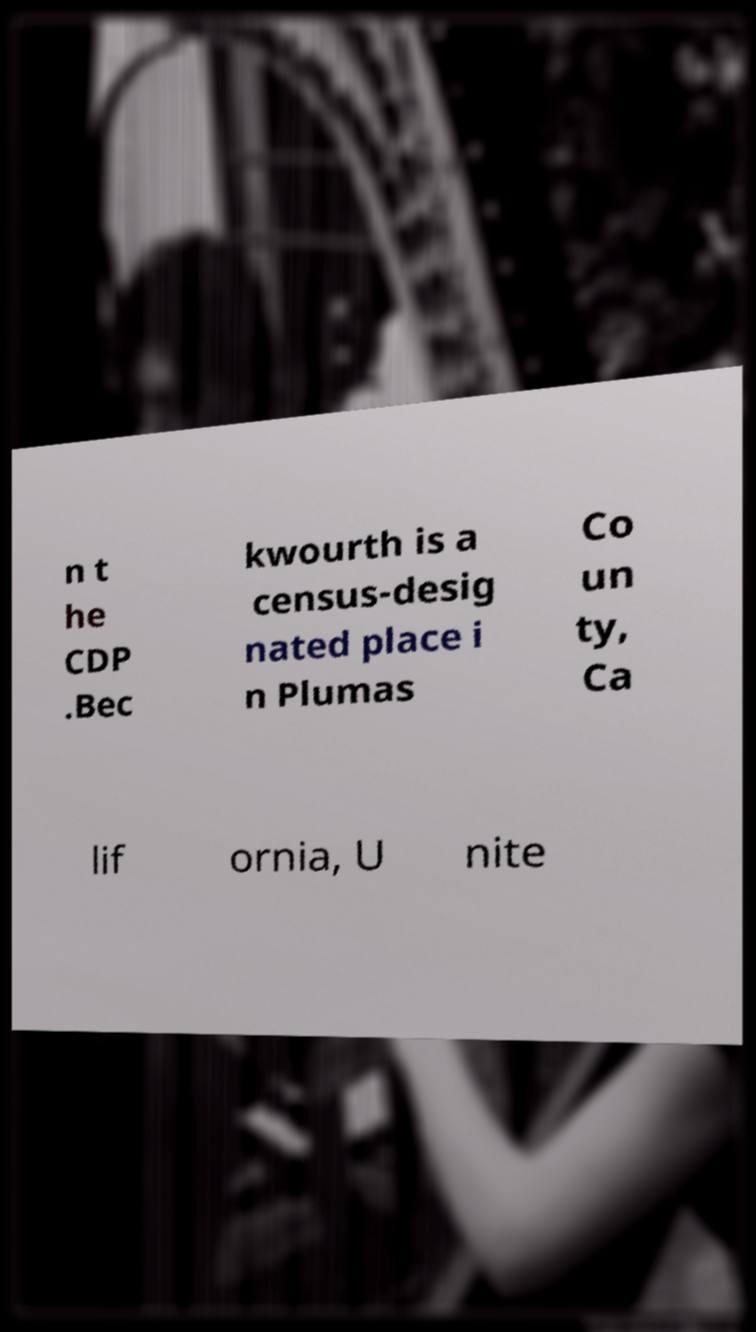What messages or text are displayed in this image? I need them in a readable, typed format. n t he CDP .Bec kwourth is a census-desig nated place i n Plumas Co un ty, Ca lif ornia, U nite 